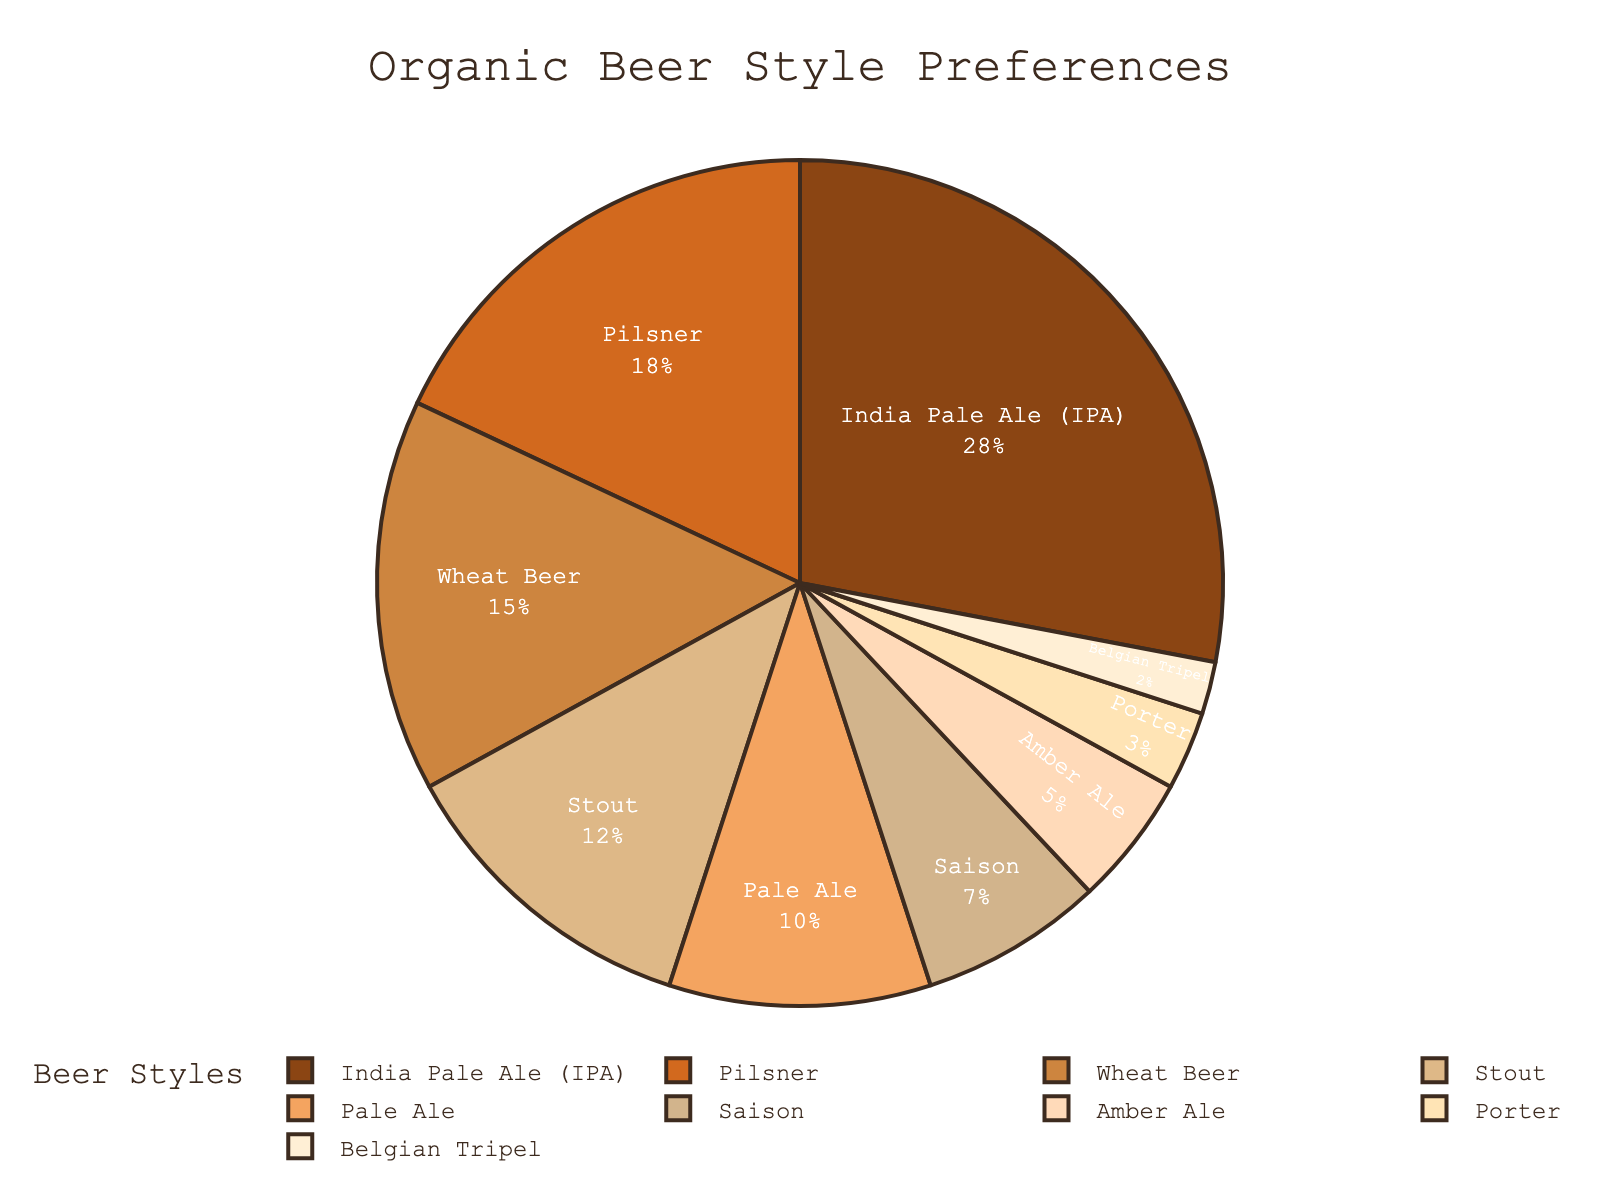What percentage of consumers prefer IPAs over Stouts? To find this, first note the percentages of IPA and Stout from the figure: IPA is 28% and Stout is 12%. Subtract Stout's percentage from IPA's: 28% - 12% = 16%.
Answer: 16% What is the total percentage of consumers who prefer Pale Ale, Saison, and Amber Ale? Start by finding the percentages for Pale Ale (10%), Saison (7%), and Amber Ale (5%). Add these percentages together: 10% + 7% + 5% = 22%.
Answer: 22% Which beer style has the smallest consumer preference? From the figure, identify the segment with the smallest slice which has the label 'Belgian Tripel' with a percentage of 2%.
Answer: Belgian Tripel Are more consumers preferring Stout or Pilsner? Check the figure to find the percentages: Stout is at 12% and Pilsner is at 18%. Since 18% is greater than 12%, more consumers prefer Pilsner.
Answer: Pilsner Which two beer styles combined capture more than 50% of consumer preferences? Look for the two highest percentages: IPA (28%) and Pilsner (18%). When combined, 28% + 18% = 46%, which is less than 50%. Next, include the third highest: IPA (28%) and Wheat Beer (15%). 28% + 15% = 43%, still less than 50%. Now include the fourth highest: IPA (28%) and Stout (12%). 28% + 18% + 15% = 61%, hence IPA and Stout combined capture more than 50%.
Answer: IPA and Stout What is the combined percentage of IPA, Pilsner, and Wheat Beer? Add the percentages for IPA (28%), Pilsner (18%), and Wheat Beer (15%). 28% + 18% + 15% = 61%.
Answer: 61% Is the combined preference for Porter and Belgian Tripel higher than 5%? Add the percentages for Porter (3%) and Belgian Tripel (2%). 3% + 2% = 5%. Since 5% is not greater than 5%, the combined preference is not higher.
Answer: No By how many percentage points does the preference for Pale Ale exceed that for Saison? Subtract the percentage for Saison (7%) from the percentage for Pale Ale (10%). 10% - 7% = 3%.
Answer: 3% 